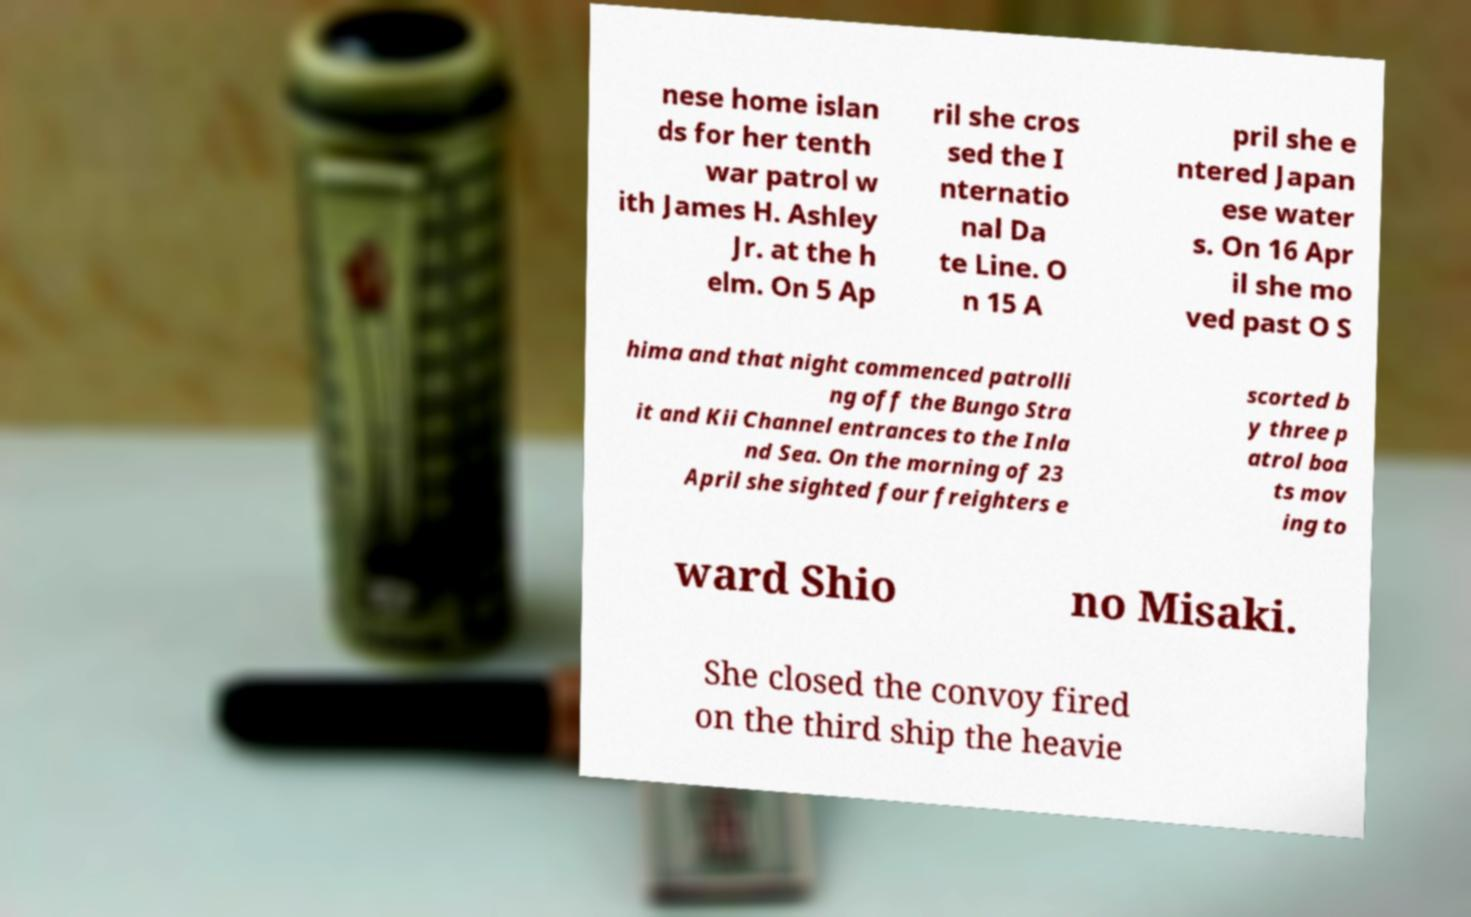Please read and relay the text visible in this image. What does it say? nese home islan ds for her tenth war patrol w ith James H. Ashley Jr. at the h elm. On 5 Ap ril she cros sed the I nternatio nal Da te Line. O n 15 A pril she e ntered Japan ese water s. On 16 Apr il she mo ved past O S hima and that night commenced patrolli ng off the Bungo Stra it and Kii Channel entrances to the Inla nd Sea. On the morning of 23 April she sighted four freighters e scorted b y three p atrol boa ts mov ing to ward Shio no Misaki. She closed the convoy fired on the third ship the heavie 